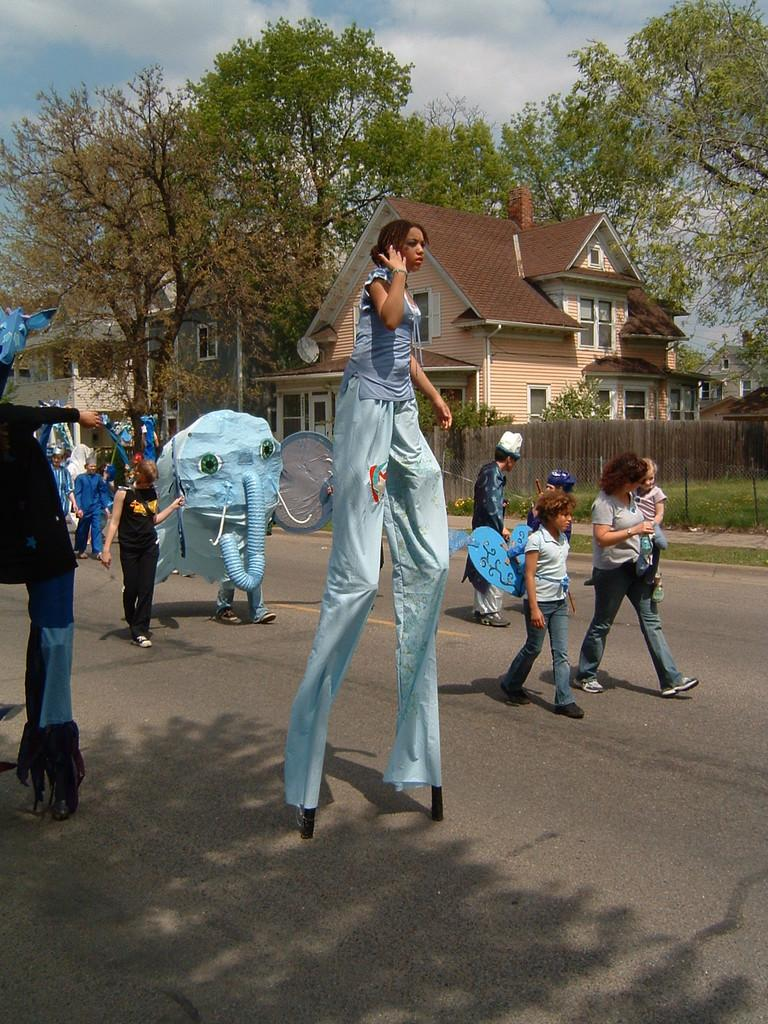What is the lady in the center of the image doing? The lady in the center of the image is walking on sticks. What can be seen in the background of the image? In the background of the image, there are people, cartoons, trees, buildings, a fence, and the sky. How many elements can be identified in the background of the image? There are seven elements visible in the background of the image: people, cartoons, trees, buildings, a fence, and the sky. What type of snow can be seen falling in the image? There is no snow present in the image. How does the lady twist her body while walking on sticks in the image? The lady is not twisting her body while walking on sticks in the image; she is simply walking on them. 